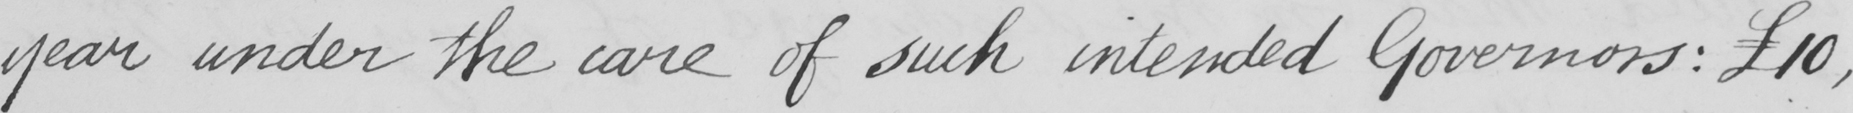Transcribe the text shown in this historical manuscript line. year under the care of such intended Governors :   £10 , 